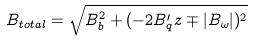<formula> <loc_0><loc_0><loc_500><loc_500>B _ { t o t a l } = \sqrt { B _ { b } ^ { 2 } + ( - 2 B ^ { \prime } _ { q } z \mp | B _ { \omega } | ) ^ { 2 } }</formula> 